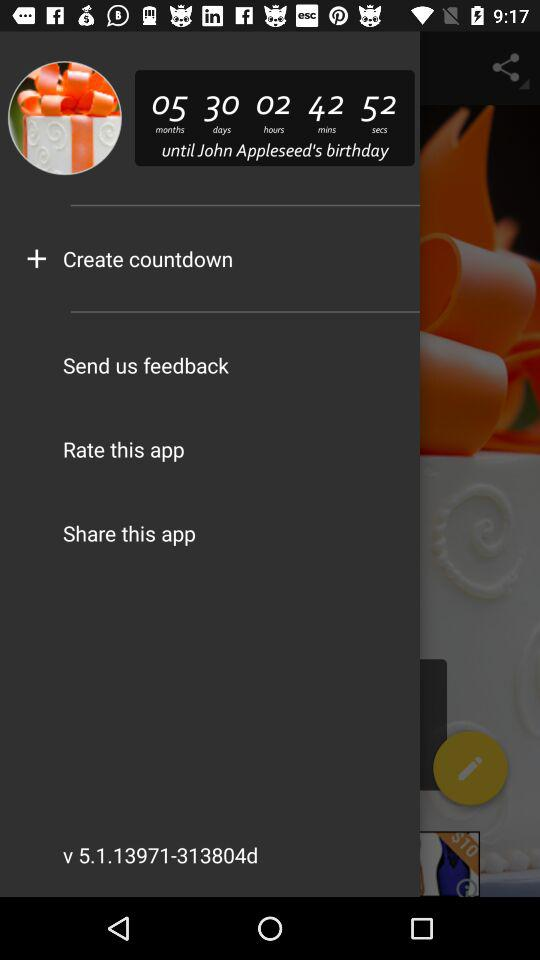What is the version? The version is 5.1.13971-313804d. 